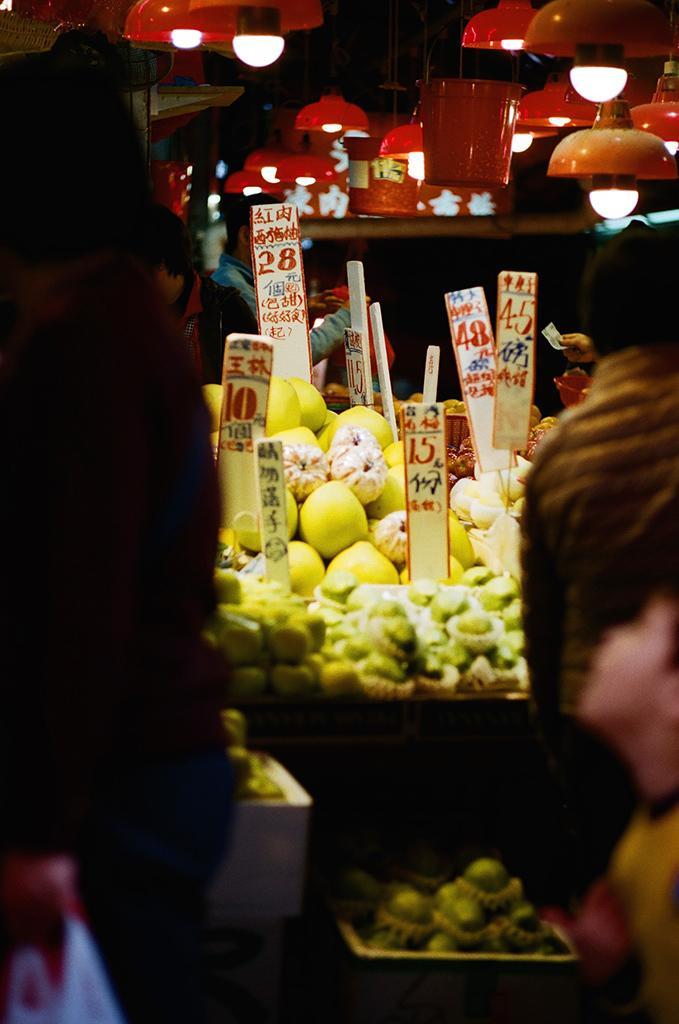How would you summarize this image in a sentence or two? In this image I can see few persons lights fruits visible in basket and some boards visible in between fruits. 